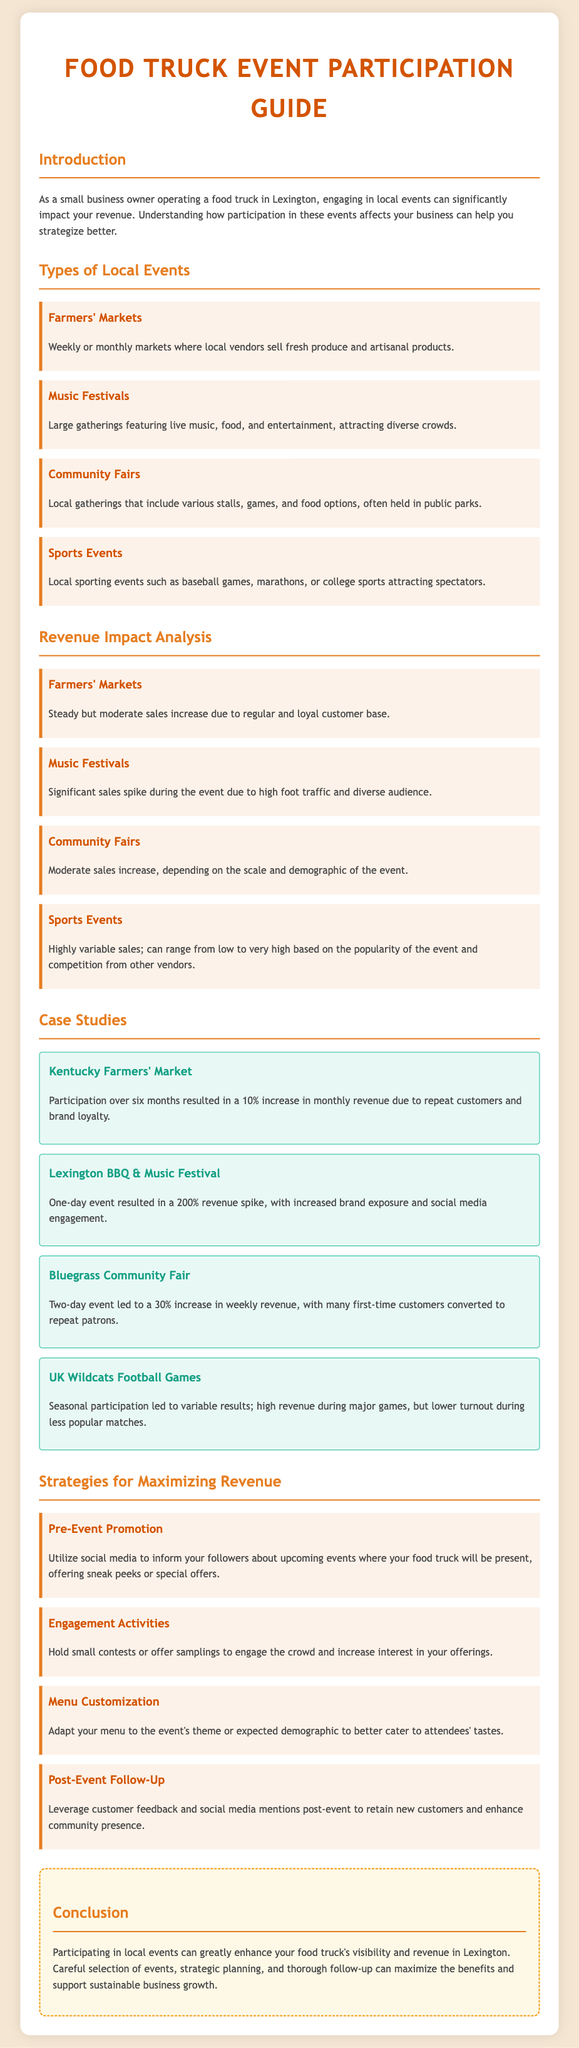What is the title of the document? The title of the document is mentioned in the header as "Food Truck Event Participation Guide."
Answer: Food Truck Event Participation Guide What type of event has a significant sales spike? The document states that "Music Festivals" lead to significant sales spikes due to high foot traffic.
Answer: Music Festivals What was the revenue increase after participating in the Kentucky Farmers' Market? The document mentions a 10% increase in monthly revenue after participation in the Kentucky Farmers' Market.
Answer: 10% What is one strategy for maximizing revenue mentioned in the document? The document lists "Pre-Event Promotion" as one of the strategies for maximizing revenue, suggesting to utilize social media for event promotion.
Answer: Pre-Event Promotion Which community event resulted in a variable revenue impact? According to the document, "UK Wildcats Football Games" showed variable revenue based on game popularity.
Answer: UK Wildcats Football Games What is the background color of the case study section? The document conveys that the background color for case studies is "light blue" as represented by "#E8F8F5."
Answer: light blue What type of local event could include games and food options? The document describes "Community Fairs" as events that include various stalls, games, and food options.
Answer: Community Fairs How much was the revenue spike at the Lexington BBQ & Music Festival? The document mentions a 200% revenue spike from participating in the Lexington BBQ & Music Festival.
Answer: 200% 